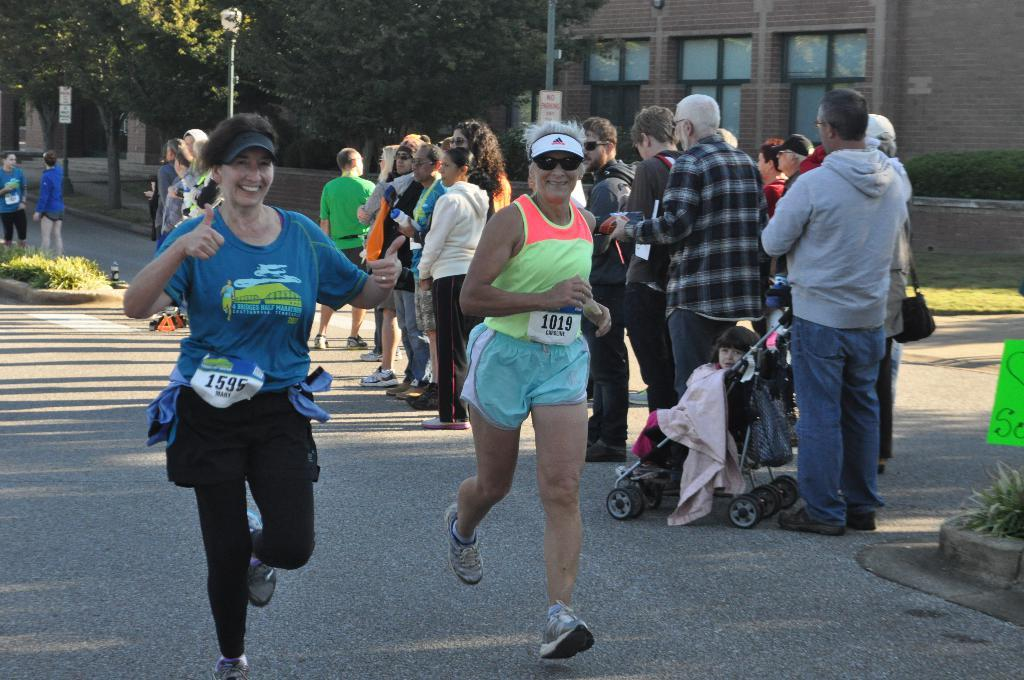What are the people in the image doing? There are persons running on the road in the center of the image. Can you describe the background of the image? There is a pole, a building, and a tree in the background of the image. Are there any other people visible in the image? Yes, there are persons in the background of the image. What type of curtain can be seen hanging from the tree in the image? There is no curtain present in the image, and the tree does not have any hanging from it. 